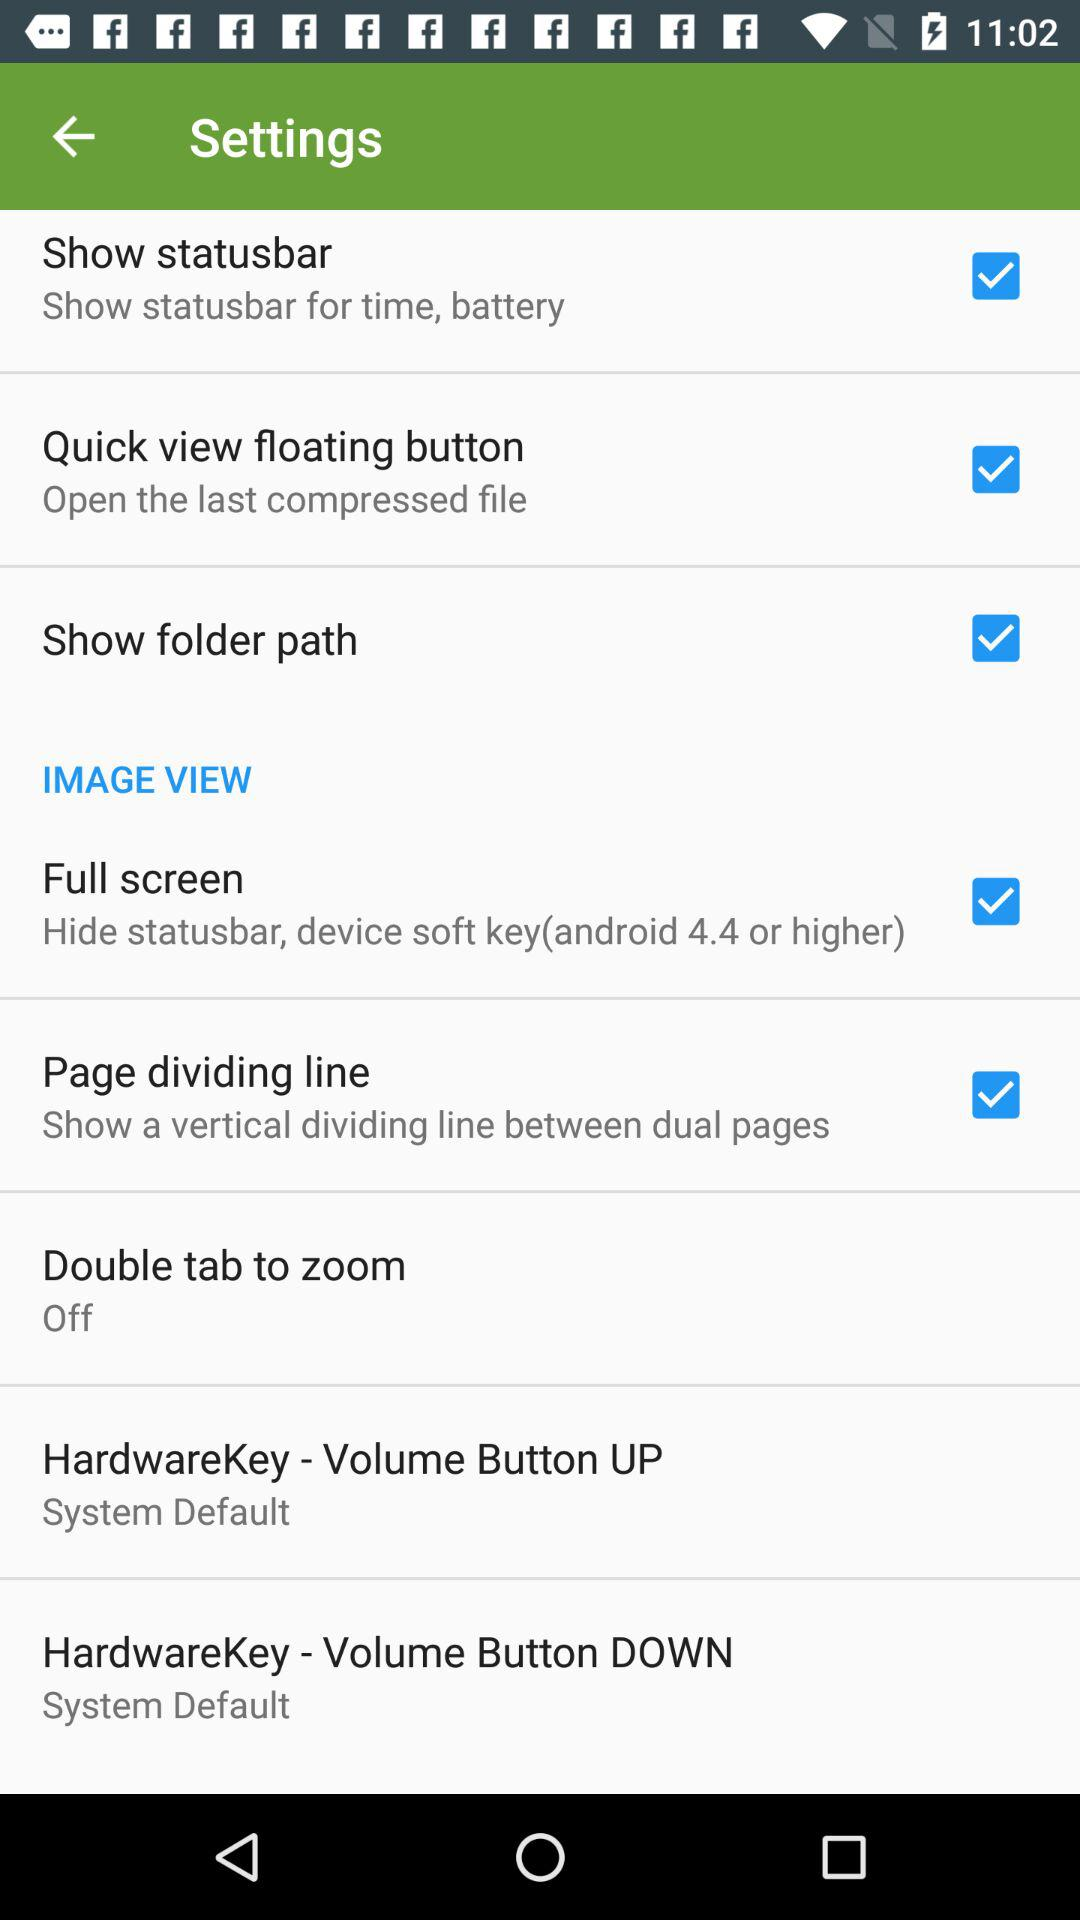What is the setting for the "Double tab to zoom"? The setting is "off". 